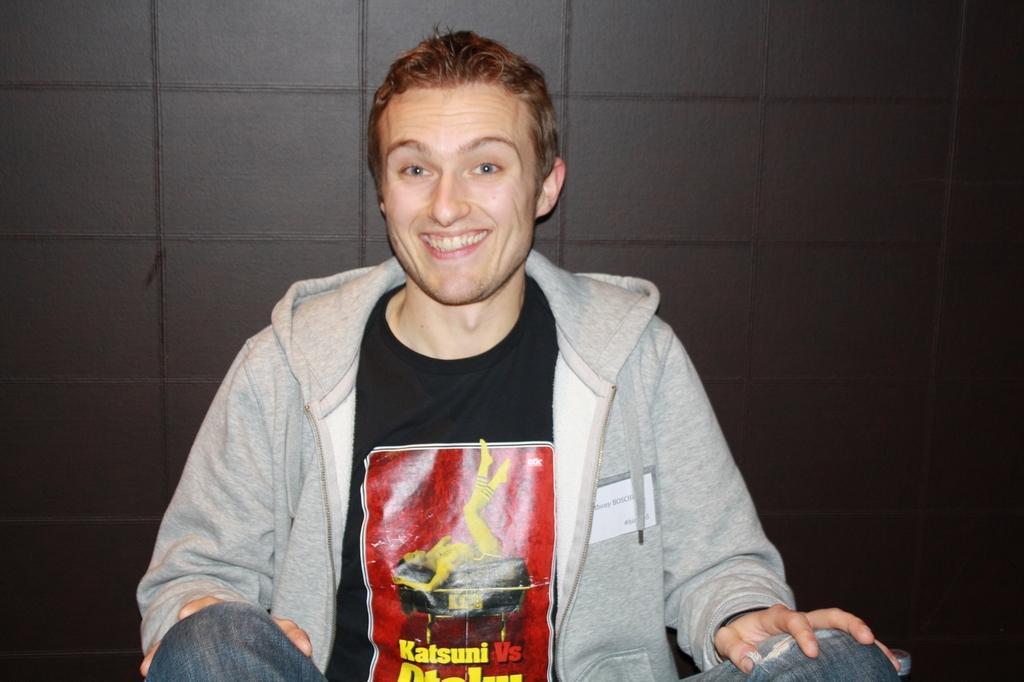In one or two sentences, can you explain what this image depicts? In this image I see a man who is sitting and I see that he is smiling and I see something is written on this t-shirt and I see the wall in the background which is brown in color. 